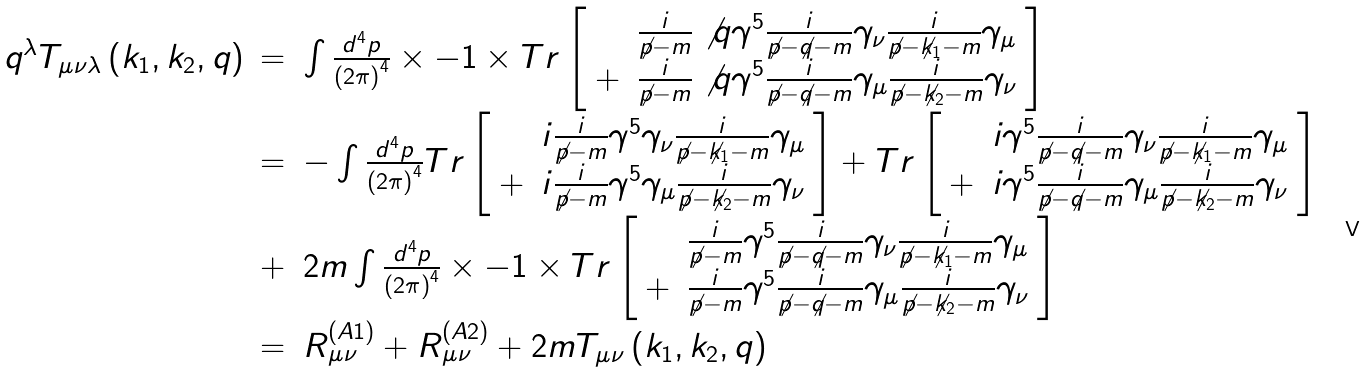Convert formula to latex. <formula><loc_0><loc_0><loc_500><loc_500>\begin{array} { r c l } q ^ { \lambda } T _ { \mu \nu \lambda } \left ( k _ { 1 } , k _ { 2 } , q \right ) & = & \int \frac { d ^ { 4 } p } { \left ( 2 \pi \right ) ^ { 4 } } \times - 1 \times T r \left [ \begin{array} { r l } & \frac { i } { \not p - m } \not q \gamma ^ { 5 } \frac { i } { \not p - \not q - m } \gamma _ { \nu } \frac { i } { \not p - \not k _ { 1 } - m } \gamma _ { \mu } \\ + & \frac { i } { \not p - m } \not q \gamma ^ { 5 } \frac { i } { \not p - \not q - m } \gamma _ { \mu } \frac { i } { \not p - \not k _ { 2 } - m } \gamma _ { \nu } \end{array} \right ] \\ & = & - \int \frac { d ^ { 4 } p } { \left ( 2 \pi \right ) ^ { 4 } } T r \left [ \begin{array} { r l } & i \frac { i } { \not p - m } \gamma ^ { 5 } \gamma _ { \nu } \frac { i } { \not p - \not k _ { 1 } - m } \gamma _ { \mu } \\ + & i \frac { i } { \not p - m } \gamma ^ { 5 } \gamma _ { \mu } \frac { i } { \not p - \not k _ { 2 } - m } \gamma _ { \nu } \end{array} \right ] + T r \left [ \begin{array} { r l } & i \gamma ^ { 5 } \frac { i } { \not p - \not q - m } \gamma _ { \nu } \frac { i } { \not p - \not k _ { 1 } - m } \gamma _ { \mu } \\ + & i \gamma ^ { 5 } \frac { i } { \not p - \not q - m } \gamma _ { \mu } \frac { i } { \not p - \not k _ { 2 } - m } \gamma _ { \nu } \end{array} \right ] \\ & + & 2 m \int \frac { d ^ { 4 } p } { \left ( 2 \pi \right ) ^ { 4 } } \times - 1 \times T r \left [ \begin{array} { r l } & \frac { i } { \not p - m } \gamma ^ { 5 } \frac { i } { \not p - \not q - m } \gamma _ { \nu } \frac { i } { \not p - \not k _ { 1 } - m } \gamma _ { \mu } \\ + & \frac { i } { \not p - m } \gamma ^ { 5 } \frac { i } { \not p - \not q - m } \gamma _ { \mu } \frac { i } { \not p - \not k _ { 2 } - m } \gamma _ { \nu } \end{array} \right ] \\ & = & R _ { \mu \nu } ^ { ( A 1 ) } + R _ { \mu \nu } ^ { ( A 2 ) } + 2 m T _ { \mu \nu } \left ( k _ { 1 } , k _ { 2 } , q \right ) \end{array}</formula> 